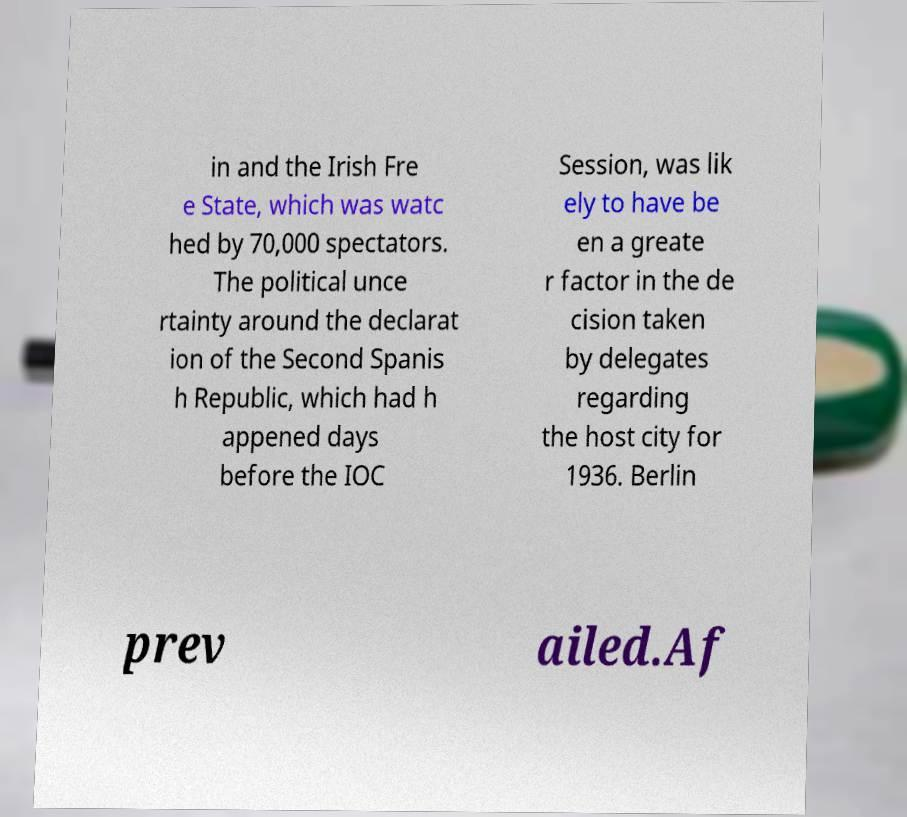Please read and relay the text visible in this image. What does it say? in and the Irish Fre e State, which was watc hed by 70,000 spectators. The political unce rtainty around the declarat ion of the Second Spanis h Republic, which had h appened days before the IOC Session, was lik ely to have be en a greate r factor in the de cision taken by delegates regarding the host city for 1936. Berlin prev ailed.Af 